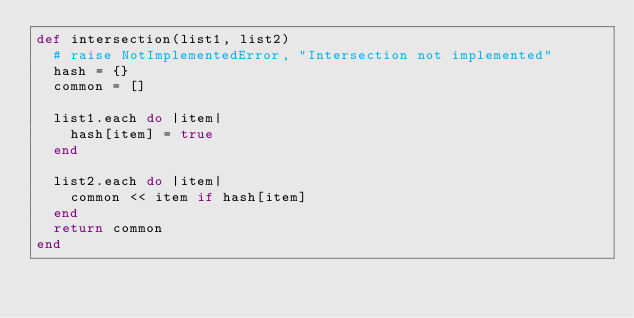<code> <loc_0><loc_0><loc_500><loc_500><_Ruby_>def intersection(list1, list2)
  # raise NotImplementedError, "Intersection not implemented"
  hash = {}
  common = []

  list1.each do |item|
    hash[item] = true
  end

  list2.each do |item|
    common << item if hash[item]
  end
  return common
end</code> 